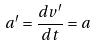<formula> <loc_0><loc_0><loc_500><loc_500>a ^ { \prime } = \frac { d v ^ { \prime } } { d t } = a</formula> 